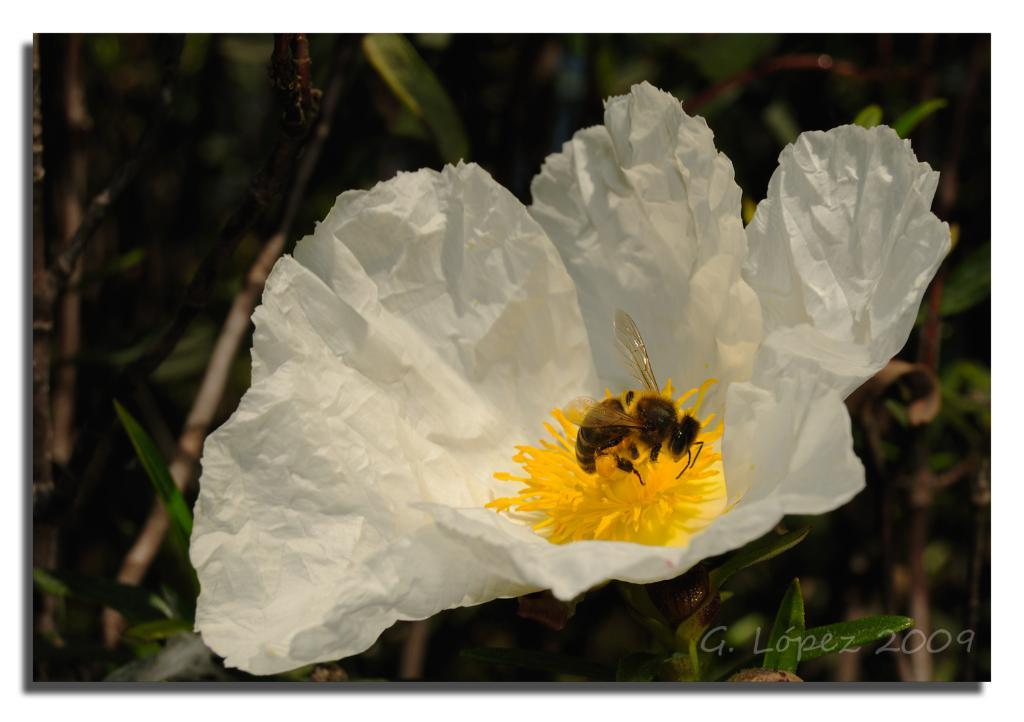What is the main subject in the center of the image? There is a flower in the center of the image. Is there anything interacting with the flower? Yes, a honey bee is on the flower. What can be seen in the background of the image? There are trees in the background of the image. What is present at the bottom of the image? There is text at the bottom of the image. What type of jail can be seen in the image? There is no jail present in the image; it features a flower with a honey bee and trees in the background. 